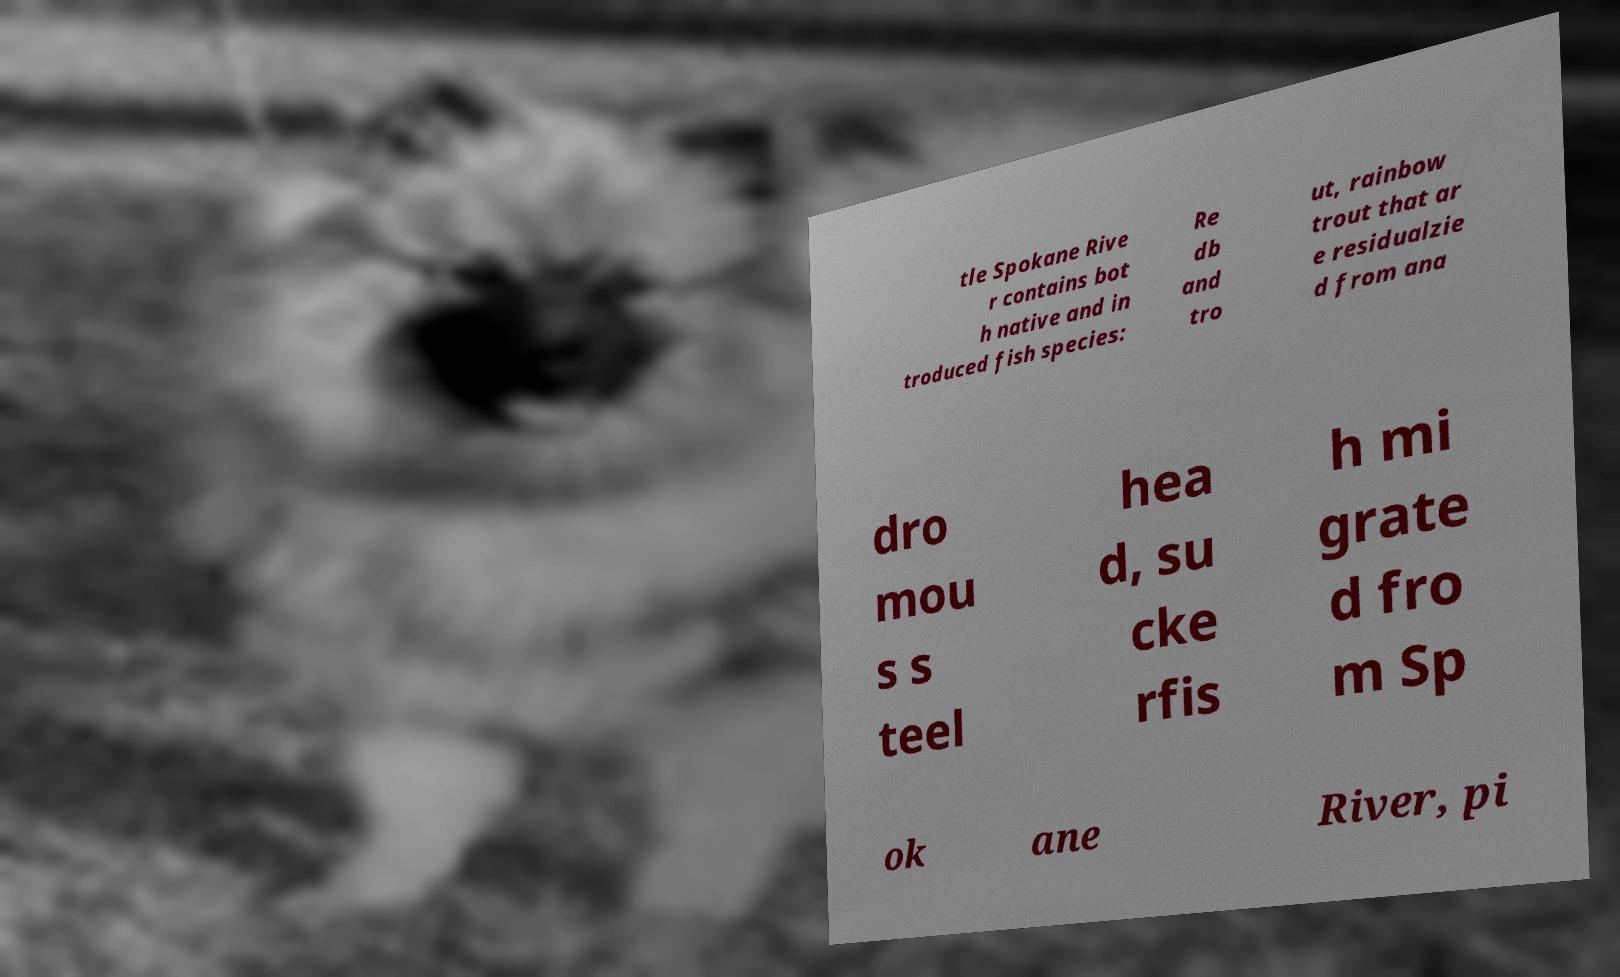Can you accurately transcribe the text from the provided image for me? tle Spokane Rive r contains bot h native and in troduced fish species: Re db and tro ut, rainbow trout that ar e residualzie d from ana dro mou s s teel hea d, su cke rfis h mi grate d fro m Sp ok ane River, pi 